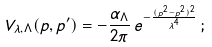<formula> <loc_0><loc_0><loc_500><loc_500>V _ { \lambda , \Lambda } ( p , p ^ { \prime } ) = - \frac { \alpha _ { \Lambda } } { 2 \pi } \, e ^ { - \frac { ( p ^ { 2 } - p ^ { 2 } ) ^ { 2 } } { \lambda ^ { 4 } } } \, ;</formula> 